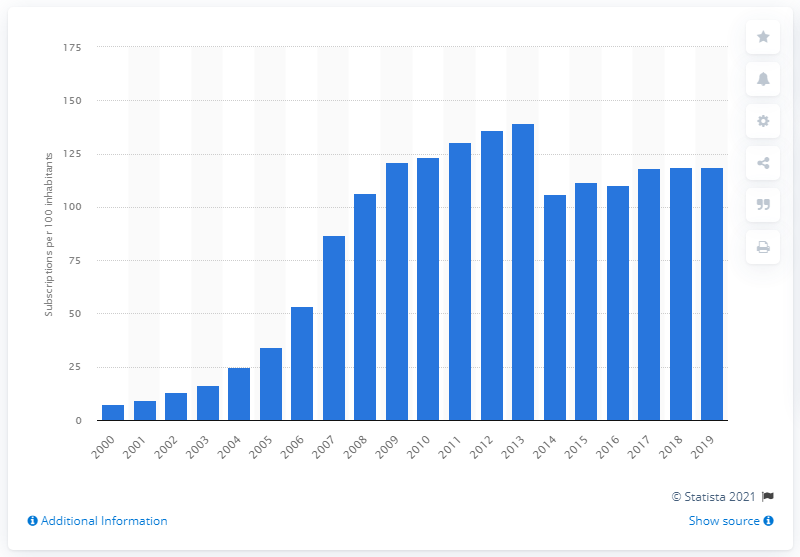Mention a couple of crucial points in this snapshot. In 2019, there were approximately 118.73 mobile cellular subscriptions for every 100 inhabitants in Guatemala. 